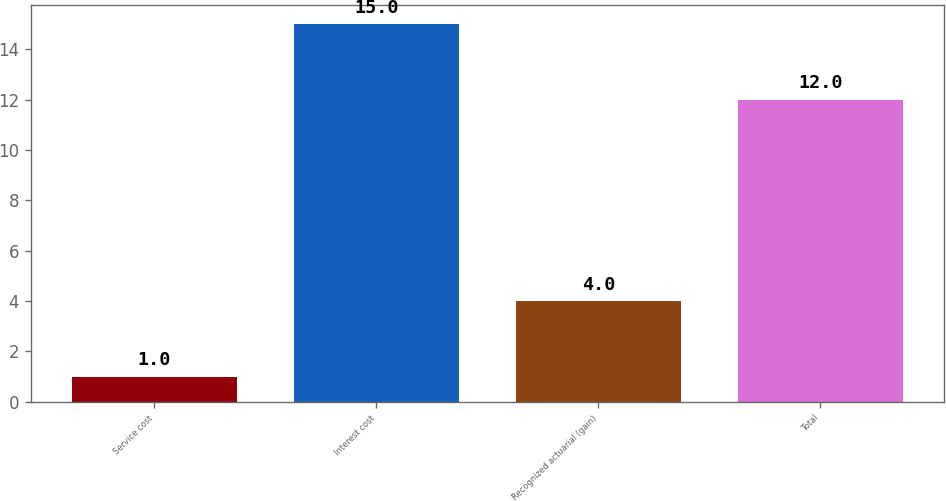Convert chart. <chart><loc_0><loc_0><loc_500><loc_500><bar_chart><fcel>Service cost<fcel>Interest cost<fcel>Recognized actuarial (gain)<fcel>Total<nl><fcel>1<fcel>15<fcel>4<fcel>12<nl></chart> 